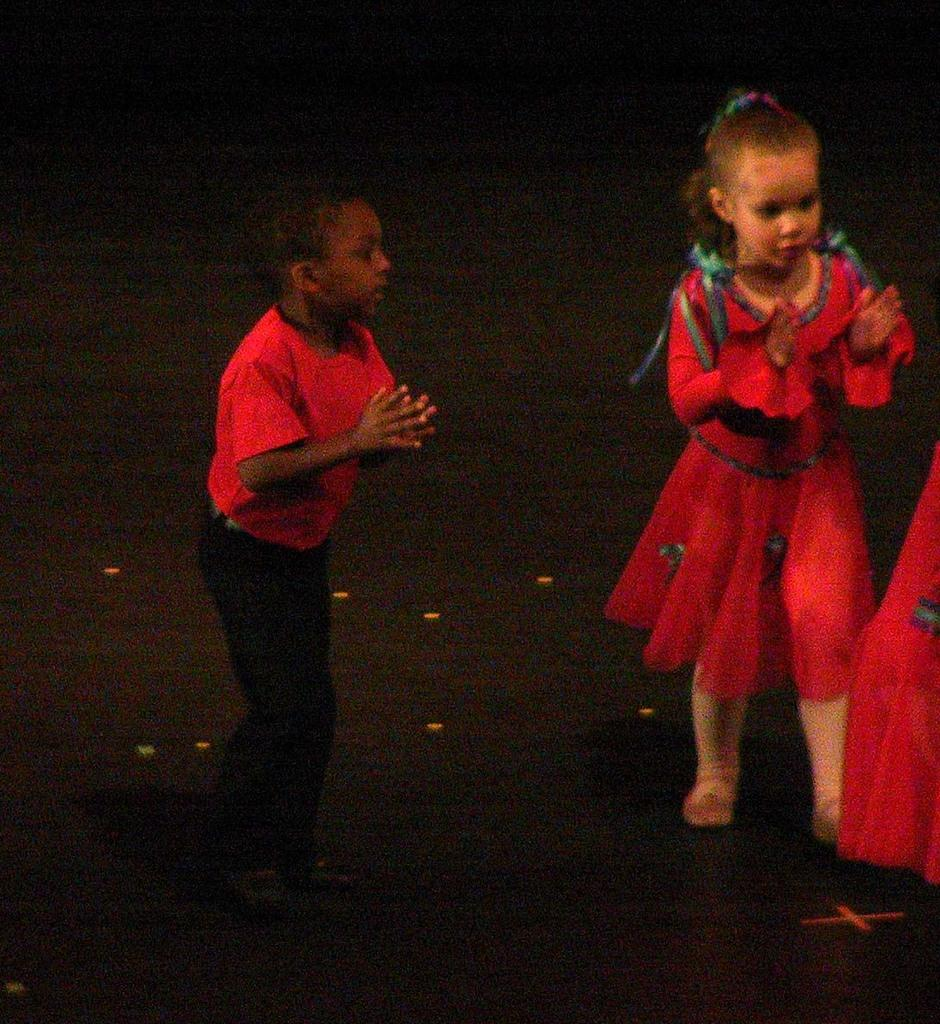How many children are in the image? There are two children in the image. What colors are featured in the children's dresses? The children are wearing red, green, and black colored dresses. Where are the children standing in the image? The children are standing on the floor. What is the color of the background in the image? The background of the image is black. What type of jam is being spread on the page in the image? There is no jam or page present in the image; it features two children wearing colorful dresses and standing on the floor against a black background. 